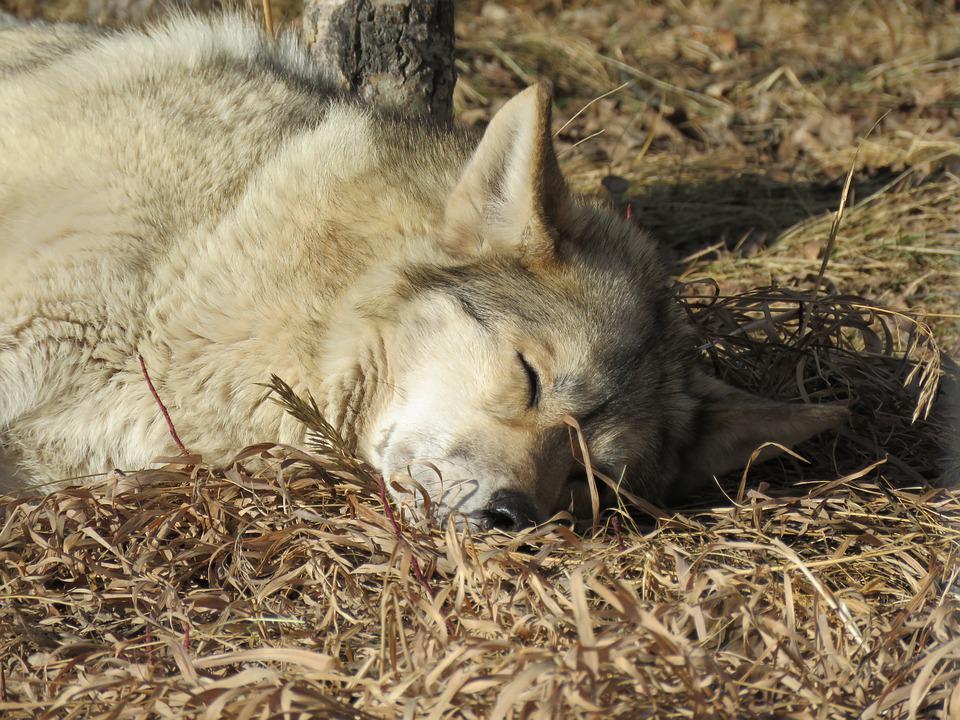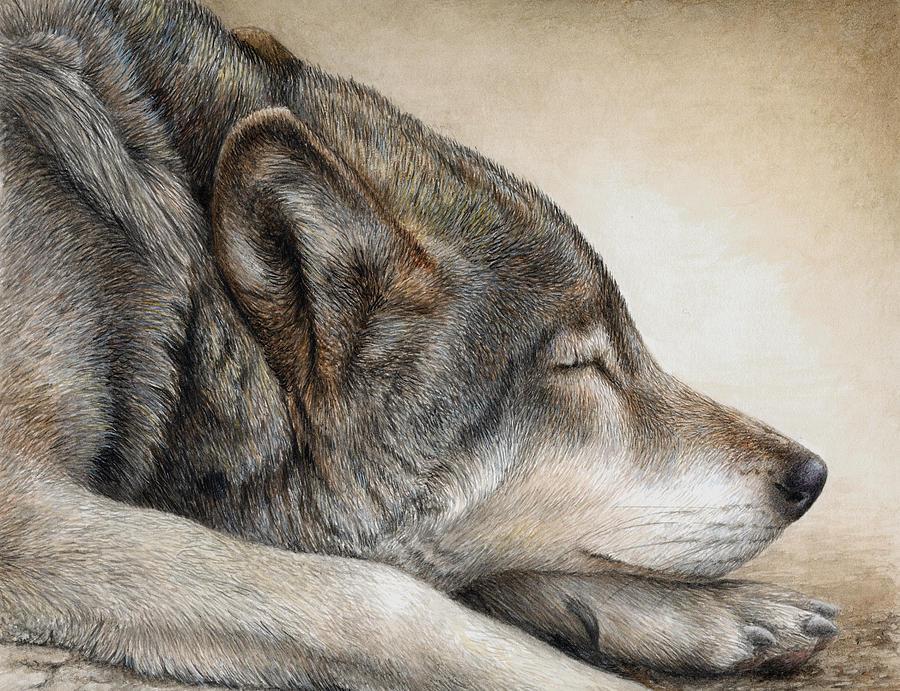The first image is the image on the left, the second image is the image on the right. Analyze the images presented: Is the assertion "The left image features a pair of wolf pups posed with one head on top of the other's head, and the right image includes an adult wolf with at least one pup." valid? Answer yes or no. No. The first image is the image on the left, the second image is the image on the right. For the images displayed, is the sentence "The left image contains two baby wolves laying down together." factually correct? Answer yes or no. No. 